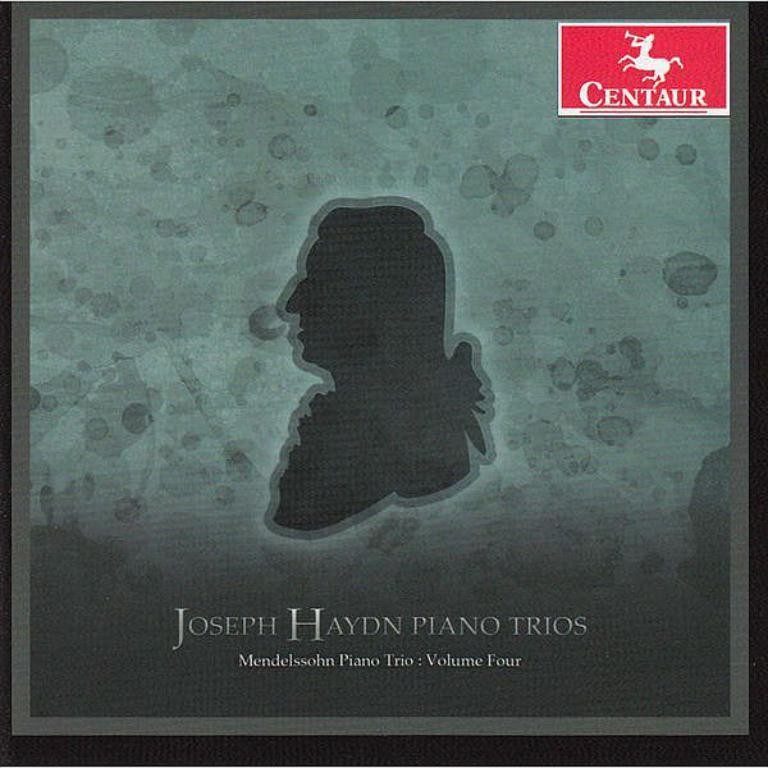<image>
Describe the image concisely. A silhouette of a man graces the cover of a CD by Joseph Haydn. 